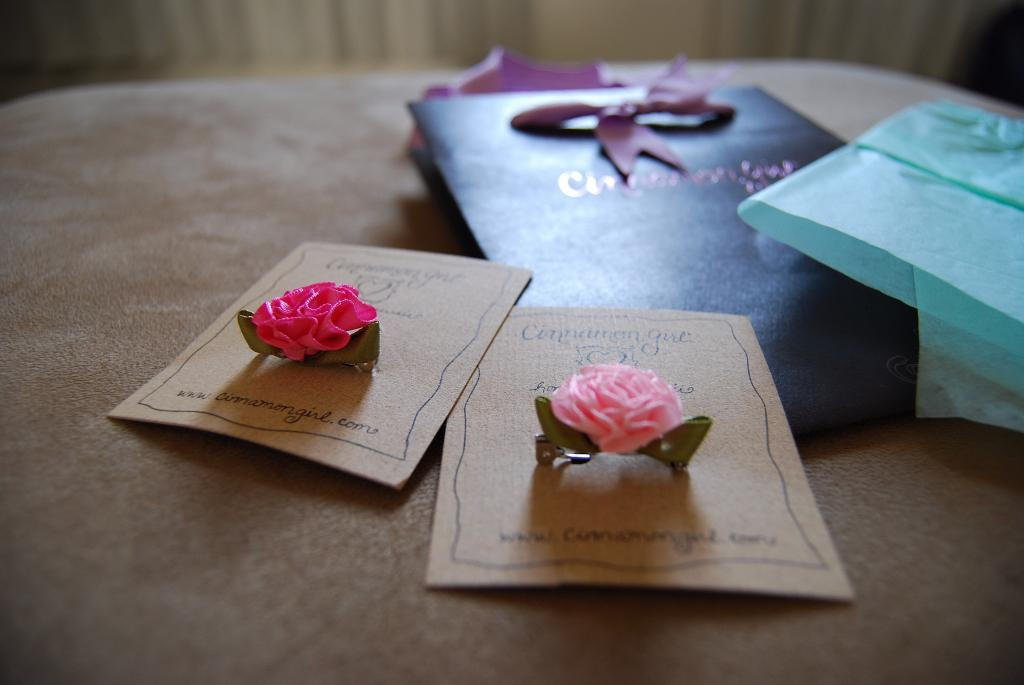What objects are present in the image? There are invitation cards in the image. Can you describe the background of the image? The background of the image is blurred. How many boys are playing in the snow in the image? There are no boys or snow present in the image; it only features invitation cards and a blurred background. 